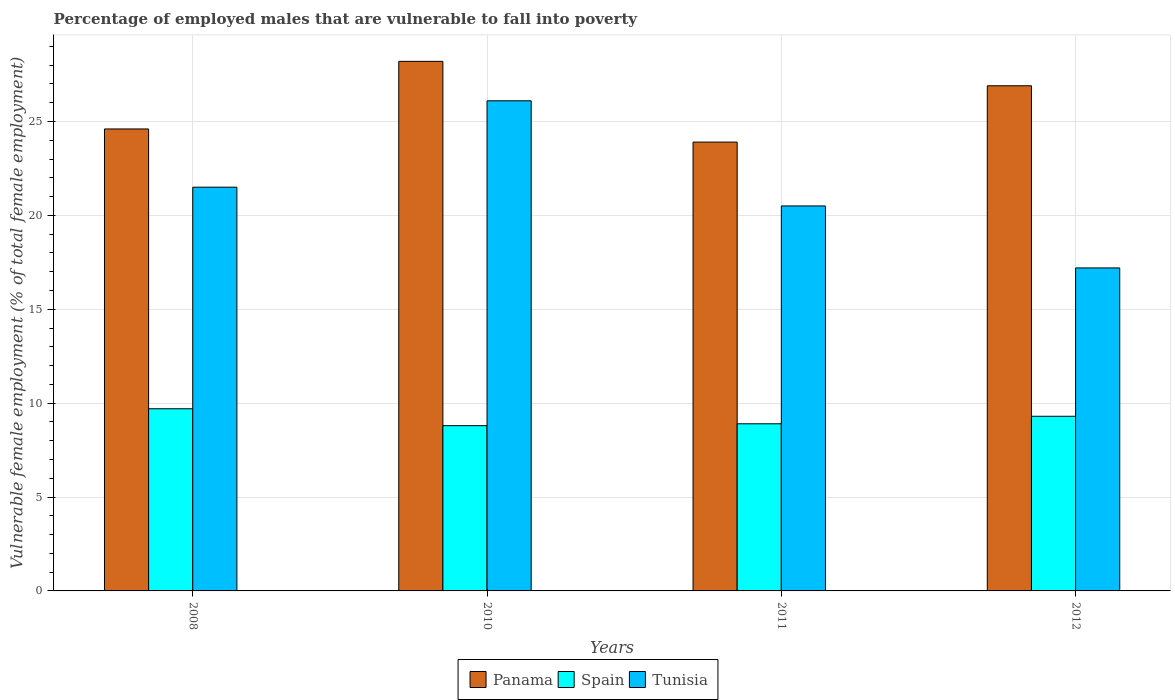How many different coloured bars are there?
Offer a very short reply. 3. Are the number of bars on each tick of the X-axis equal?
Provide a short and direct response. Yes. How many bars are there on the 2nd tick from the left?
Provide a short and direct response. 3. What is the percentage of employed males who are vulnerable to fall into poverty in Tunisia in 2012?
Provide a short and direct response. 17.2. Across all years, what is the maximum percentage of employed males who are vulnerable to fall into poverty in Panama?
Your answer should be very brief. 28.2. Across all years, what is the minimum percentage of employed males who are vulnerable to fall into poverty in Panama?
Your answer should be very brief. 23.9. In which year was the percentage of employed males who are vulnerable to fall into poverty in Spain maximum?
Make the answer very short. 2008. What is the total percentage of employed males who are vulnerable to fall into poverty in Tunisia in the graph?
Your answer should be very brief. 85.3. What is the difference between the percentage of employed males who are vulnerable to fall into poverty in Panama in 2010 and that in 2012?
Offer a very short reply. 1.3. What is the difference between the percentage of employed males who are vulnerable to fall into poverty in Panama in 2011 and the percentage of employed males who are vulnerable to fall into poverty in Spain in 2010?
Offer a terse response. 15.1. What is the average percentage of employed males who are vulnerable to fall into poverty in Panama per year?
Provide a short and direct response. 25.9. In the year 2012, what is the difference between the percentage of employed males who are vulnerable to fall into poverty in Tunisia and percentage of employed males who are vulnerable to fall into poverty in Panama?
Keep it short and to the point. -9.7. What is the ratio of the percentage of employed males who are vulnerable to fall into poverty in Tunisia in 2011 to that in 2012?
Give a very brief answer. 1.19. Is the difference between the percentage of employed males who are vulnerable to fall into poverty in Tunisia in 2010 and 2012 greater than the difference between the percentage of employed males who are vulnerable to fall into poverty in Panama in 2010 and 2012?
Give a very brief answer. Yes. What is the difference between the highest and the second highest percentage of employed males who are vulnerable to fall into poverty in Spain?
Provide a succinct answer. 0.4. What is the difference between the highest and the lowest percentage of employed males who are vulnerable to fall into poverty in Spain?
Your answer should be compact. 0.9. In how many years, is the percentage of employed males who are vulnerable to fall into poverty in Tunisia greater than the average percentage of employed males who are vulnerable to fall into poverty in Tunisia taken over all years?
Give a very brief answer. 2. Is the sum of the percentage of employed males who are vulnerable to fall into poverty in Tunisia in 2010 and 2011 greater than the maximum percentage of employed males who are vulnerable to fall into poverty in Panama across all years?
Give a very brief answer. Yes. What does the 1st bar from the left in 2010 represents?
Give a very brief answer. Panama. What does the 1st bar from the right in 2010 represents?
Offer a terse response. Tunisia. How many years are there in the graph?
Your answer should be compact. 4. Does the graph contain any zero values?
Keep it short and to the point. No. Does the graph contain grids?
Provide a succinct answer. Yes. How many legend labels are there?
Provide a succinct answer. 3. What is the title of the graph?
Provide a succinct answer. Percentage of employed males that are vulnerable to fall into poverty. What is the label or title of the X-axis?
Make the answer very short. Years. What is the label or title of the Y-axis?
Your response must be concise. Vulnerable female employment (% of total female employment). What is the Vulnerable female employment (% of total female employment) of Panama in 2008?
Your response must be concise. 24.6. What is the Vulnerable female employment (% of total female employment) of Spain in 2008?
Your answer should be very brief. 9.7. What is the Vulnerable female employment (% of total female employment) of Panama in 2010?
Ensure brevity in your answer.  28.2. What is the Vulnerable female employment (% of total female employment) of Spain in 2010?
Keep it short and to the point. 8.8. What is the Vulnerable female employment (% of total female employment) of Tunisia in 2010?
Give a very brief answer. 26.1. What is the Vulnerable female employment (% of total female employment) of Panama in 2011?
Your answer should be compact. 23.9. What is the Vulnerable female employment (% of total female employment) in Spain in 2011?
Provide a short and direct response. 8.9. What is the Vulnerable female employment (% of total female employment) of Panama in 2012?
Your answer should be compact. 26.9. What is the Vulnerable female employment (% of total female employment) in Spain in 2012?
Provide a succinct answer. 9.3. What is the Vulnerable female employment (% of total female employment) in Tunisia in 2012?
Make the answer very short. 17.2. Across all years, what is the maximum Vulnerable female employment (% of total female employment) in Panama?
Keep it short and to the point. 28.2. Across all years, what is the maximum Vulnerable female employment (% of total female employment) of Spain?
Offer a terse response. 9.7. Across all years, what is the maximum Vulnerable female employment (% of total female employment) in Tunisia?
Your answer should be very brief. 26.1. Across all years, what is the minimum Vulnerable female employment (% of total female employment) of Panama?
Your answer should be very brief. 23.9. Across all years, what is the minimum Vulnerable female employment (% of total female employment) in Spain?
Offer a terse response. 8.8. Across all years, what is the minimum Vulnerable female employment (% of total female employment) in Tunisia?
Give a very brief answer. 17.2. What is the total Vulnerable female employment (% of total female employment) of Panama in the graph?
Your response must be concise. 103.6. What is the total Vulnerable female employment (% of total female employment) in Spain in the graph?
Your answer should be compact. 36.7. What is the total Vulnerable female employment (% of total female employment) of Tunisia in the graph?
Ensure brevity in your answer.  85.3. What is the difference between the Vulnerable female employment (% of total female employment) of Spain in 2008 and that in 2010?
Keep it short and to the point. 0.9. What is the difference between the Vulnerable female employment (% of total female employment) in Tunisia in 2008 and that in 2010?
Offer a very short reply. -4.6. What is the difference between the Vulnerable female employment (% of total female employment) of Spain in 2008 and that in 2011?
Provide a short and direct response. 0.8. What is the difference between the Vulnerable female employment (% of total female employment) of Panama in 2010 and that in 2011?
Your response must be concise. 4.3. What is the difference between the Vulnerable female employment (% of total female employment) in Panama in 2011 and that in 2012?
Your response must be concise. -3. What is the difference between the Vulnerable female employment (% of total female employment) of Panama in 2008 and the Vulnerable female employment (% of total female employment) of Tunisia in 2010?
Keep it short and to the point. -1.5. What is the difference between the Vulnerable female employment (% of total female employment) in Spain in 2008 and the Vulnerable female employment (% of total female employment) in Tunisia in 2010?
Your answer should be compact. -16.4. What is the difference between the Vulnerable female employment (% of total female employment) in Spain in 2008 and the Vulnerable female employment (% of total female employment) in Tunisia in 2011?
Offer a very short reply. -10.8. What is the difference between the Vulnerable female employment (% of total female employment) in Panama in 2008 and the Vulnerable female employment (% of total female employment) in Spain in 2012?
Make the answer very short. 15.3. What is the difference between the Vulnerable female employment (% of total female employment) in Panama in 2008 and the Vulnerable female employment (% of total female employment) in Tunisia in 2012?
Give a very brief answer. 7.4. What is the difference between the Vulnerable female employment (% of total female employment) of Panama in 2010 and the Vulnerable female employment (% of total female employment) of Spain in 2011?
Keep it short and to the point. 19.3. What is the difference between the Vulnerable female employment (% of total female employment) of Panama in 2010 and the Vulnerable female employment (% of total female employment) of Spain in 2012?
Your response must be concise. 18.9. What is the difference between the Vulnerable female employment (% of total female employment) in Panama in 2011 and the Vulnerable female employment (% of total female employment) in Spain in 2012?
Provide a short and direct response. 14.6. What is the difference between the Vulnerable female employment (% of total female employment) in Spain in 2011 and the Vulnerable female employment (% of total female employment) in Tunisia in 2012?
Provide a succinct answer. -8.3. What is the average Vulnerable female employment (% of total female employment) in Panama per year?
Ensure brevity in your answer.  25.9. What is the average Vulnerable female employment (% of total female employment) of Spain per year?
Offer a terse response. 9.18. What is the average Vulnerable female employment (% of total female employment) of Tunisia per year?
Provide a succinct answer. 21.32. In the year 2008, what is the difference between the Vulnerable female employment (% of total female employment) of Panama and Vulnerable female employment (% of total female employment) of Spain?
Give a very brief answer. 14.9. In the year 2008, what is the difference between the Vulnerable female employment (% of total female employment) of Spain and Vulnerable female employment (% of total female employment) of Tunisia?
Give a very brief answer. -11.8. In the year 2010, what is the difference between the Vulnerable female employment (% of total female employment) of Panama and Vulnerable female employment (% of total female employment) of Spain?
Provide a succinct answer. 19.4. In the year 2010, what is the difference between the Vulnerable female employment (% of total female employment) in Panama and Vulnerable female employment (% of total female employment) in Tunisia?
Offer a terse response. 2.1. In the year 2010, what is the difference between the Vulnerable female employment (% of total female employment) of Spain and Vulnerable female employment (% of total female employment) of Tunisia?
Make the answer very short. -17.3. In the year 2011, what is the difference between the Vulnerable female employment (% of total female employment) of Panama and Vulnerable female employment (% of total female employment) of Spain?
Your response must be concise. 15. In the year 2011, what is the difference between the Vulnerable female employment (% of total female employment) in Panama and Vulnerable female employment (% of total female employment) in Tunisia?
Give a very brief answer. 3.4. In the year 2012, what is the difference between the Vulnerable female employment (% of total female employment) of Panama and Vulnerable female employment (% of total female employment) of Spain?
Ensure brevity in your answer.  17.6. In the year 2012, what is the difference between the Vulnerable female employment (% of total female employment) in Panama and Vulnerable female employment (% of total female employment) in Tunisia?
Give a very brief answer. 9.7. In the year 2012, what is the difference between the Vulnerable female employment (% of total female employment) of Spain and Vulnerable female employment (% of total female employment) of Tunisia?
Provide a short and direct response. -7.9. What is the ratio of the Vulnerable female employment (% of total female employment) of Panama in 2008 to that in 2010?
Provide a succinct answer. 0.87. What is the ratio of the Vulnerable female employment (% of total female employment) of Spain in 2008 to that in 2010?
Make the answer very short. 1.1. What is the ratio of the Vulnerable female employment (% of total female employment) in Tunisia in 2008 to that in 2010?
Ensure brevity in your answer.  0.82. What is the ratio of the Vulnerable female employment (% of total female employment) in Panama in 2008 to that in 2011?
Your answer should be very brief. 1.03. What is the ratio of the Vulnerable female employment (% of total female employment) of Spain in 2008 to that in 2011?
Provide a succinct answer. 1.09. What is the ratio of the Vulnerable female employment (% of total female employment) of Tunisia in 2008 to that in 2011?
Provide a short and direct response. 1.05. What is the ratio of the Vulnerable female employment (% of total female employment) of Panama in 2008 to that in 2012?
Your answer should be compact. 0.91. What is the ratio of the Vulnerable female employment (% of total female employment) of Spain in 2008 to that in 2012?
Offer a terse response. 1.04. What is the ratio of the Vulnerable female employment (% of total female employment) in Panama in 2010 to that in 2011?
Provide a short and direct response. 1.18. What is the ratio of the Vulnerable female employment (% of total female employment) of Tunisia in 2010 to that in 2011?
Ensure brevity in your answer.  1.27. What is the ratio of the Vulnerable female employment (% of total female employment) of Panama in 2010 to that in 2012?
Your answer should be very brief. 1.05. What is the ratio of the Vulnerable female employment (% of total female employment) in Spain in 2010 to that in 2012?
Make the answer very short. 0.95. What is the ratio of the Vulnerable female employment (% of total female employment) of Tunisia in 2010 to that in 2012?
Offer a terse response. 1.52. What is the ratio of the Vulnerable female employment (% of total female employment) in Panama in 2011 to that in 2012?
Give a very brief answer. 0.89. What is the ratio of the Vulnerable female employment (% of total female employment) of Tunisia in 2011 to that in 2012?
Your response must be concise. 1.19. What is the difference between the highest and the second highest Vulnerable female employment (% of total female employment) of Tunisia?
Make the answer very short. 4.6. What is the difference between the highest and the lowest Vulnerable female employment (% of total female employment) in Panama?
Offer a terse response. 4.3. What is the difference between the highest and the lowest Vulnerable female employment (% of total female employment) of Tunisia?
Provide a short and direct response. 8.9. 